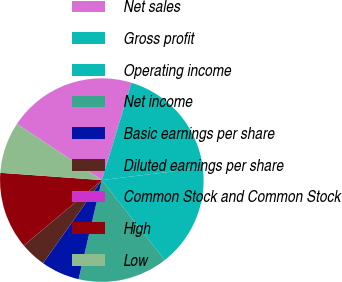<chart> <loc_0><loc_0><loc_500><loc_500><pie_chart><fcel>Net sales<fcel>Gross profit<fcel>Operating income<fcel>Net income<fcel>Basic earnings per share<fcel>Diluted earnings per share<fcel>Common Stock and Common Stock<fcel>High<fcel>Low<nl><fcel>20.4%<fcel>18.36%<fcel>16.32%<fcel>14.28%<fcel>6.13%<fcel>4.09%<fcel>0.01%<fcel>12.24%<fcel>8.16%<nl></chart> 